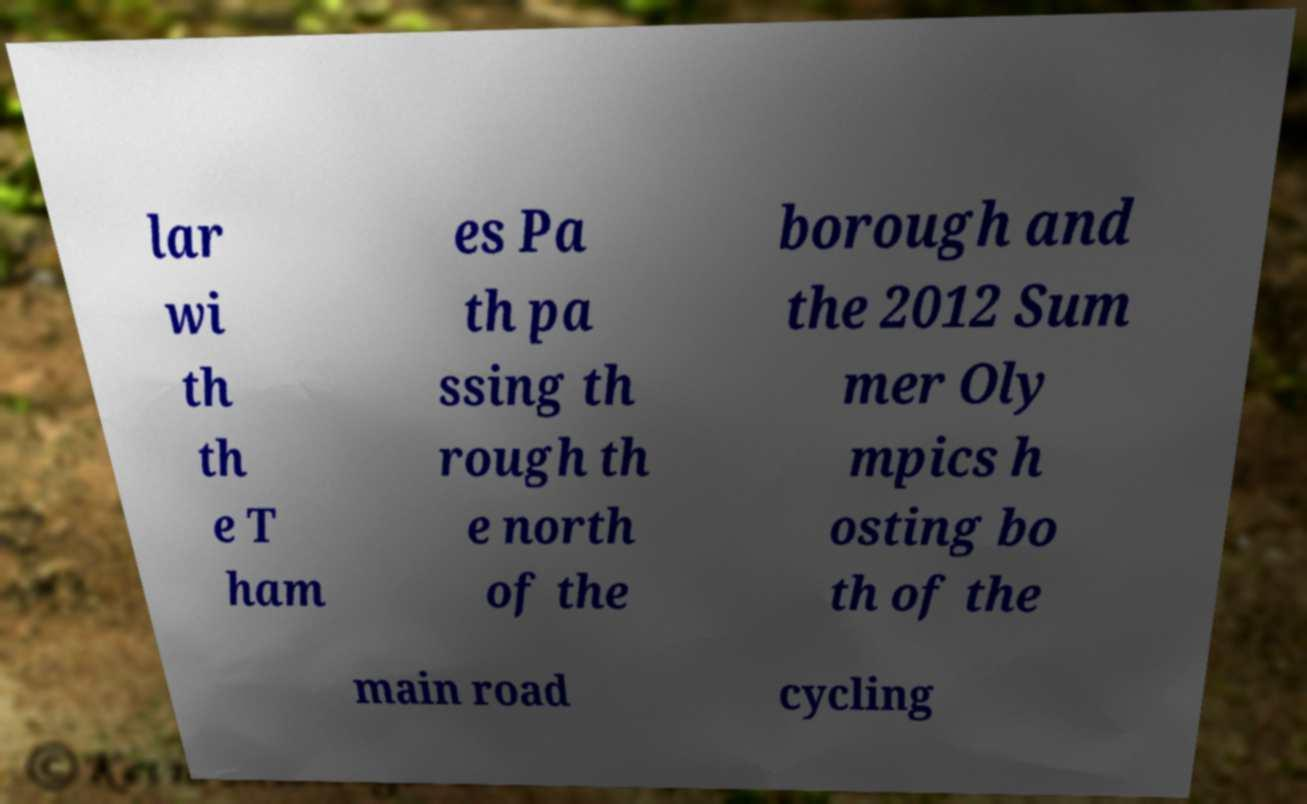Could you extract and type out the text from this image? lar wi th th e T ham es Pa th pa ssing th rough th e north of the borough and the 2012 Sum mer Oly mpics h osting bo th of the main road cycling 